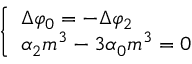<formula> <loc_0><loc_0><loc_500><loc_500>\left \{ \begin{array} { l } { \Delta \varphi _ { 0 } = - \Delta \varphi _ { 2 } } \\ { \alpha _ { 2 } m ^ { 3 } - 3 \alpha _ { 0 } m ^ { 3 } = 0 } \end{array}</formula> 